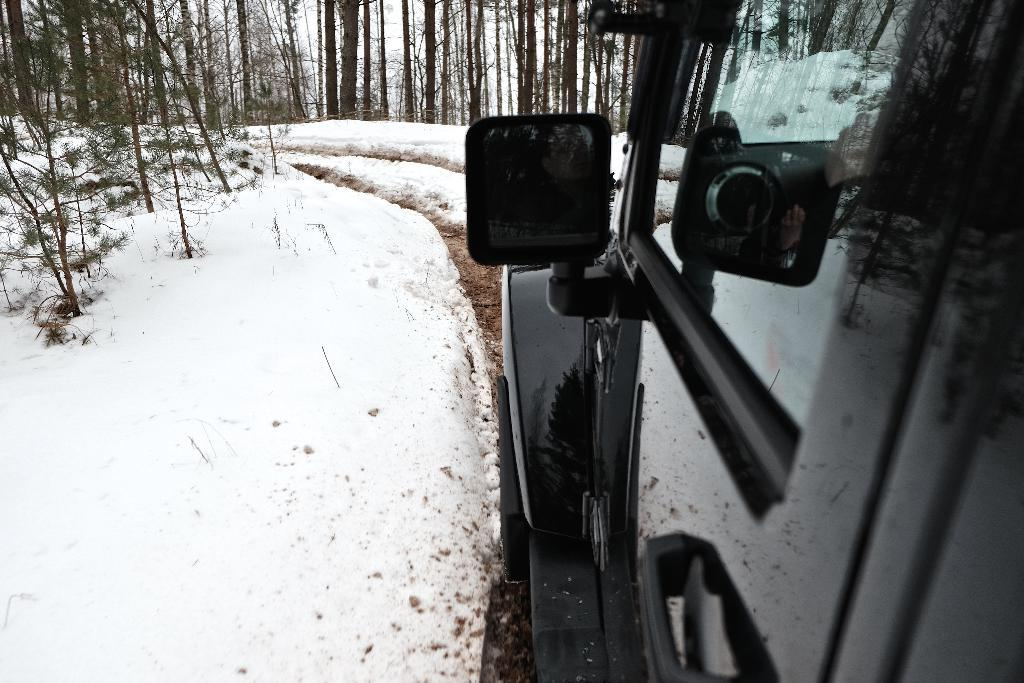What is the main subject of the image? The main subject of the image is a car. Can you describe the car in the image? The car is black in color. What can be seen on the ground on the left side of the image? There is snow on the ground on the left side of the image. What is visible in the background of the image? There are trees in the background of the image. Where is the maid standing in the image? There is no maid present in the image. What is the limit of the doll's movement in the image? There is no doll present in the image, so there is no limit to its movement. 